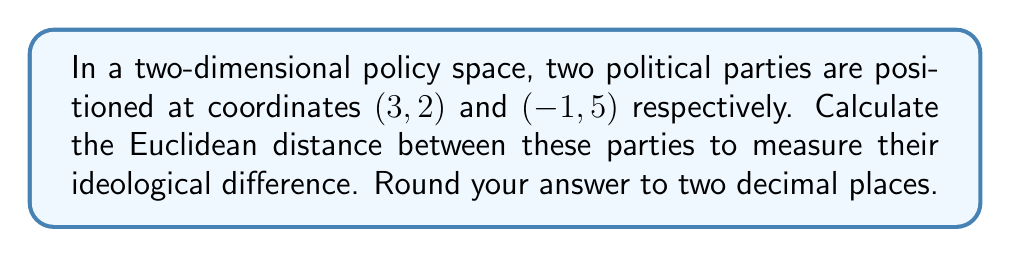Can you answer this question? To solve this problem, we need to use the Euclidean distance formula in a two-dimensional space. This formula is derived from the Pythagorean theorem.

Given:
- Party A is at coordinates (3, 2)
- Party B is at coordinates (-1, 5)

The Euclidean distance formula is:

$$ d = \sqrt{(x_2 - x_1)^2 + (y_2 - y_1)^2} $$

Where:
- $(x_1, y_1)$ are the coordinates of the first point (Party A)
- $(x_2, y_2)$ are the coordinates of the second point (Party B)

Let's substitute the values:

$x_1 = 3, y_1 = 2$
$x_2 = -1, y_2 = 5$

$$ d = \sqrt{(-1 - 3)^2 + (5 - 2)^2} $$

Simplify:

$$ d = \sqrt{(-4)^2 + (3)^2} $$
$$ d = \sqrt{16 + 9} $$
$$ d = \sqrt{25} $$
$$ d = 5 $$

The Euclidean distance between the two parties is 5 units in the policy space.

This distance provides a quantitative measure of the ideological difference between the two parties based on their positions in the two-dimensional policy space.
Answer: 5.00 